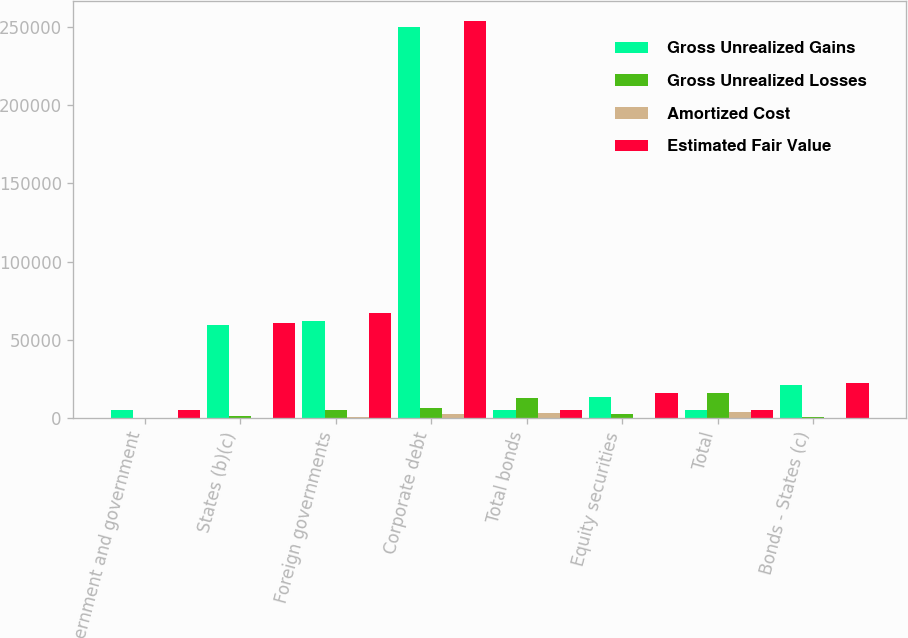Convert chart to OTSL. <chart><loc_0><loc_0><loc_500><loc_500><stacked_bar_chart><ecel><fcel>US government and government<fcel>States (b)(c)<fcel>Foreign governments<fcel>Corporate debt<fcel>Total bonds<fcel>Equity securities<fcel>Total<fcel>Bonds - States (c)<nl><fcel>Gross Unrealized Gains<fcel>5386<fcel>59785<fcel>62153<fcel>249839<fcel>5407<fcel>13147<fcel>5407<fcel>21437<nl><fcel>Gross Unrealized Losses<fcel>106<fcel>1056<fcel>5428<fcel>6519<fcel>13109<fcel>2813<fcel>15922<fcel>731<nl><fcel>Amortized Cost<fcel>130<fcel>210<fcel>436<fcel>2627<fcel>3403<fcel>159<fcel>3562<fcel>14<nl><fcel>Estimated Fair Value<fcel>5362<fcel>60631<fcel>67145<fcel>253731<fcel>5407<fcel>15801<fcel>5407<fcel>22154<nl></chart> 